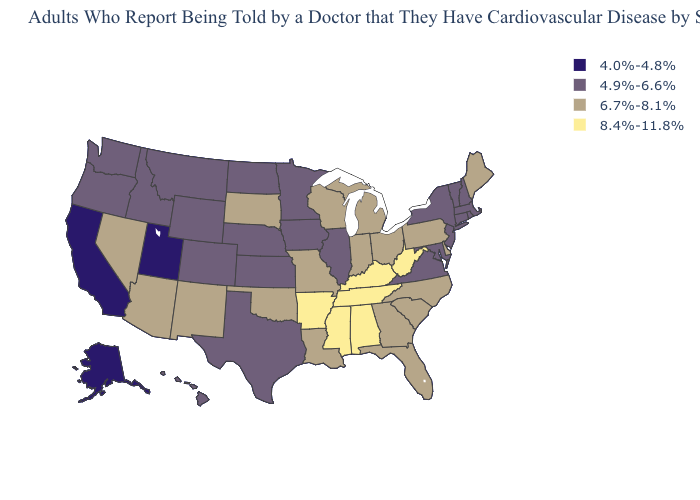What is the value of Michigan?
Give a very brief answer. 6.7%-8.1%. Name the states that have a value in the range 8.4%-11.8%?
Write a very short answer. Alabama, Arkansas, Kentucky, Mississippi, Tennessee, West Virginia. What is the value of Alabama?
Write a very short answer. 8.4%-11.8%. Name the states that have a value in the range 4.9%-6.6%?
Write a very short answer. Colorado, Connecticut, Hawaii, Idaho, Illinois, Iowa, Kansas, Maryland, Massachusetts, Minnesota, Montana, Nebraska, New Hampshire, New Jersey, New York, North Dakota, Oregon, Rhode Island, Texas, Vermont, Virginia, Washington, Wyoming. What is the lowest value in the West?
Be succinct. 4.0%-4.8%. Name the states that have a value in the range 4.9%-6.6%?
Write a very short answer. Colorado, Connecticut, Hawaii, Idaho, Illinois, Iowa, Kansas, Maryland, Massachusetts, Minnesota, Montana, Nebraska, New Hampshire, New Jersey, New York, North Dakota, Oregon, Rhode Island, Texas, Vermont, Virginia, Washington, Wyoming. Does New Hampshire have the highest value in the Northeast?
Short answer required. No. Does Indiana have the lowest value in the MidWest?
Write a very short answer. No. What is the value of Texas?
Answer briefly. 4.9%-6.6%. What is the value of Tennessee?
Answer briefly. 8.4%-11.8%. What is the value of Wisconsin?
Keep it brief. 6.7%-8.1%. Which states have the lowest value in the West?
Write a very short answer. Alaska, California, Utah. What is the highest value in the South ?
Short answer required. 8.4%-11.8%. Which states have the lowest value in the USA?
Answer briefly. Alaska, California, Utah. Which states hav the highest value in the West?
Concise answer only. Arizona, Nevada, New Mexico. 